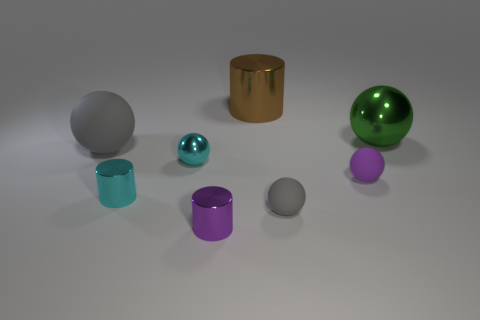Subtract all large matte balls. How many balls are left? 4 Subtract all blue cylinders. How many gray spheres are left? 2 Add 1 big green objects. How many objects exist? 9 Subtract 3 balls. How many balls are left? 2 Subtract all purple spheres. How many spheres are left? 4 Subtract all spheres. How many objects are left? 3 Add 2 brown things. How many brown things exist? 3 Subtract 2 gray spheres. How many objects are left? 6 Subtract all blue balls. Subtract all cyan cylinders. How many balls are left? 5 Subtract all tiny gray balls. Subtract all small purple spheres. How many objects are left? 6 